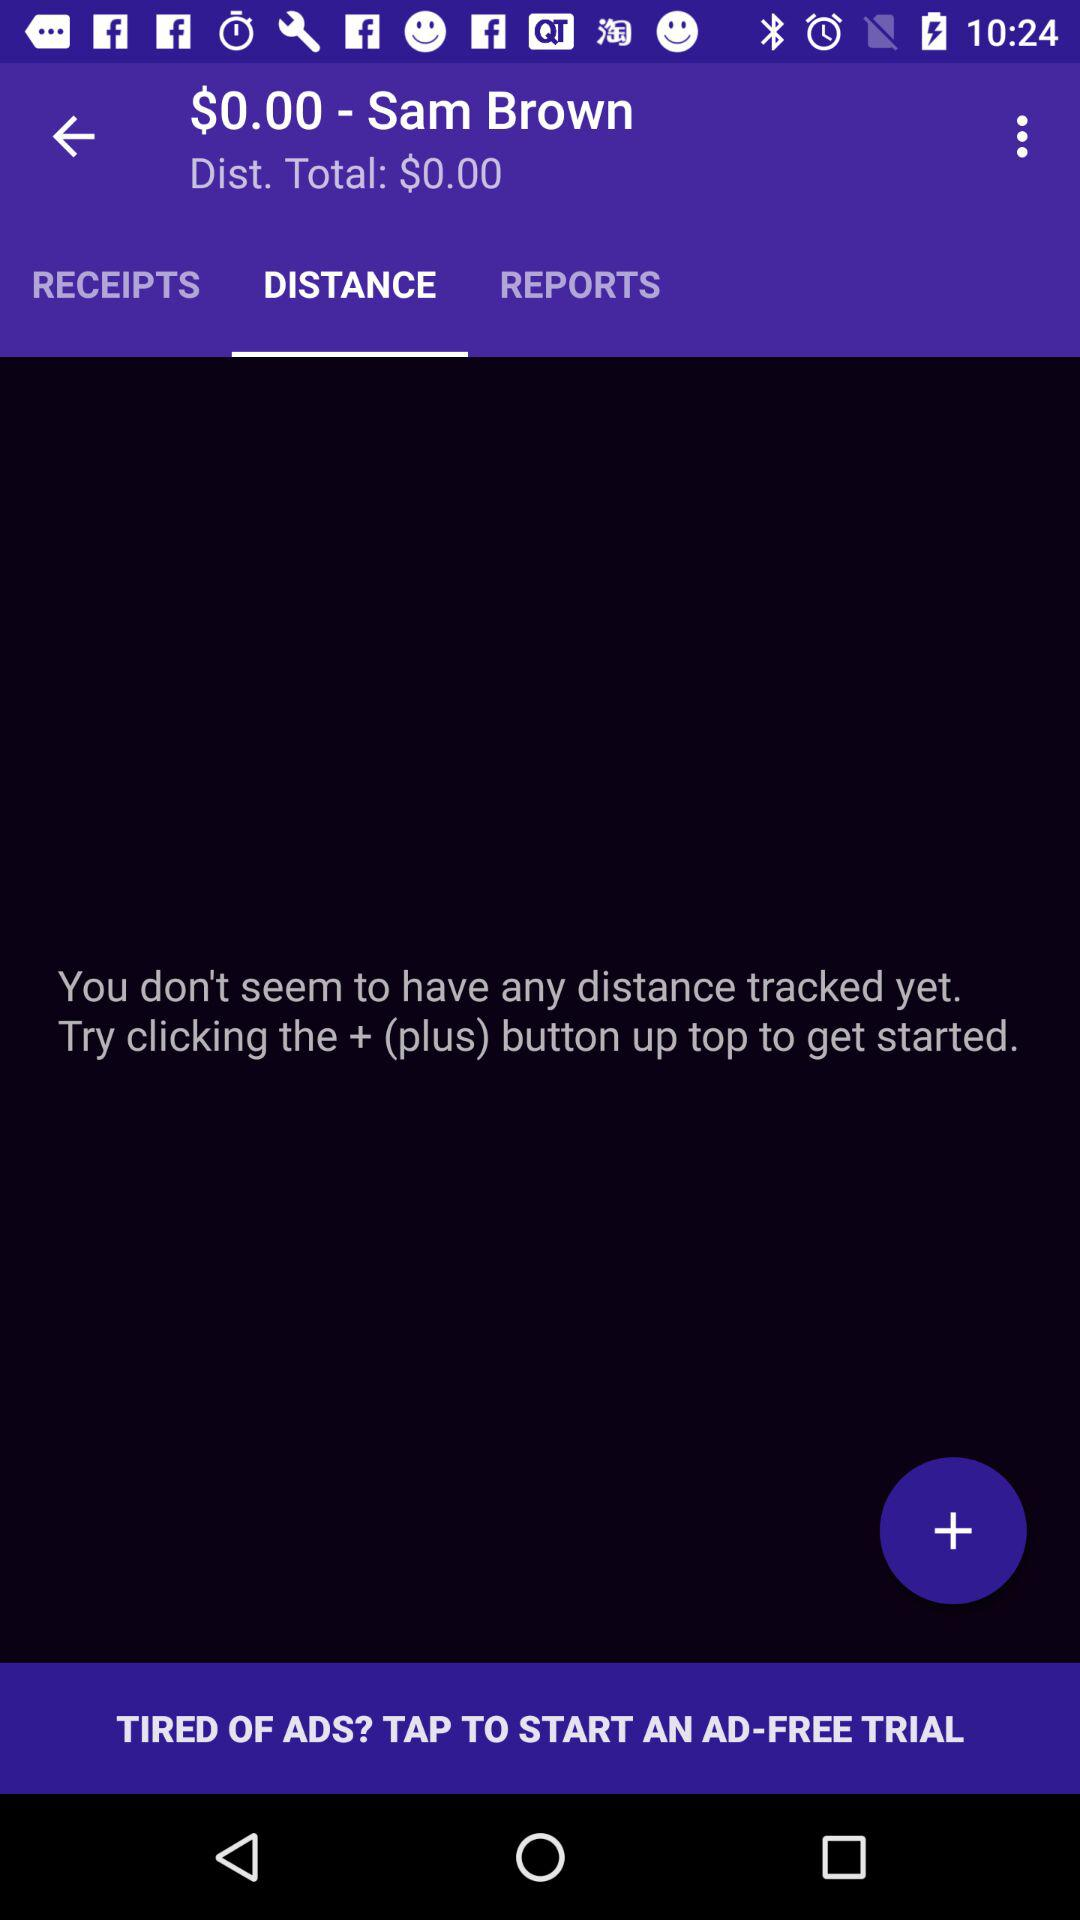How much is the total distance?
Answer the question using a single word or phrase. $0.00 